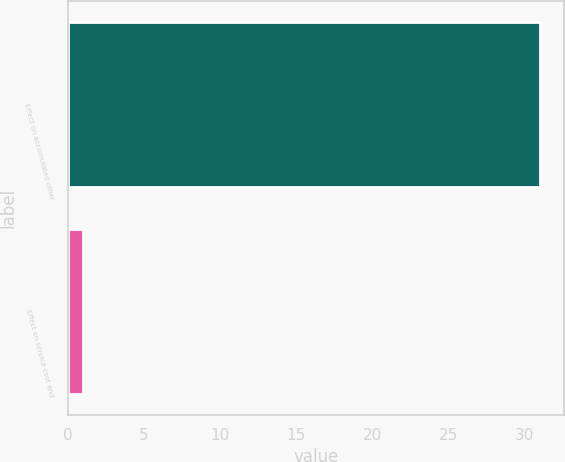Convert chart to OTSL. <chart><loc_0><loc_0><loc_500><loc_500><bar_chart><fcel>Effect on accumulated other<fcel>Effect on service cost and<nl><fcel>31<fcel>1<nl></chart> 